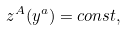<formula> <loc_0><loc_0><loc_500><loc_500>z ^ { A } ( y ^ { a } ) = c o n s t ,</formula> 